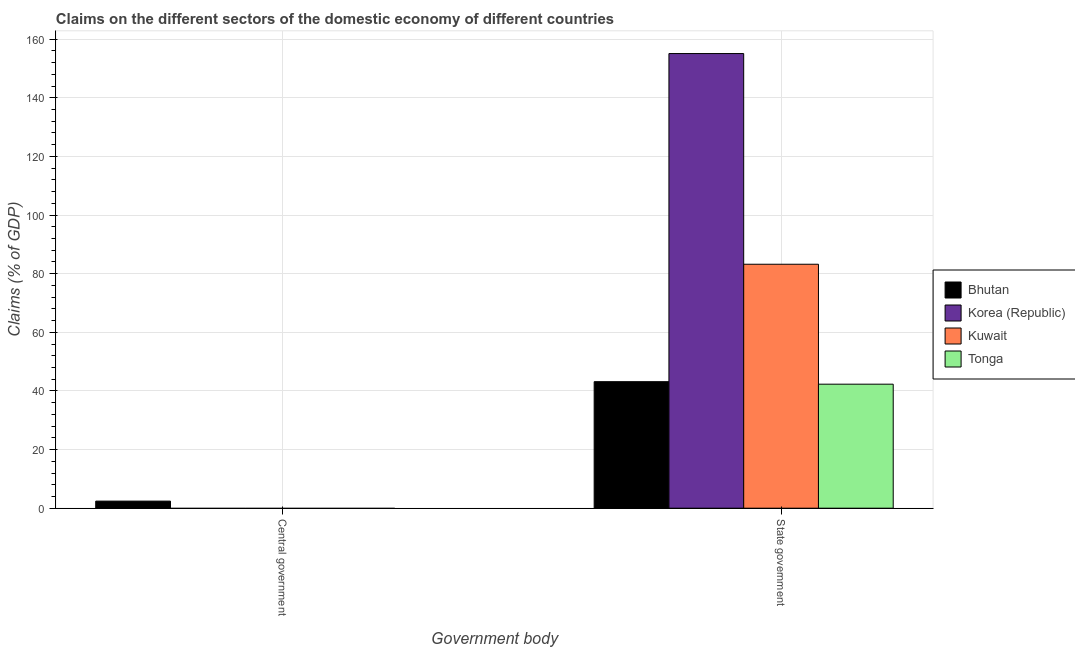How many different coloured bars are there?
Your response must be concise. 4. Are the number of bars per tick equal to the number of legend labels?
Your response must be concise. No. How many bars are there on the 1st tick from the left?
Keep it short and to the point. 1. What is the label of the 2nd group of bars from the left?
Offer a very short reply. State government. Across all countries, what is the maximum claims on central government?
Offer a very short reply. 2.42. Across all countries, what is the minimum claims on state government?
Provide a short and direct response. 42.3. In which country was the claims on state government maximum?
Give a very brief answer. Korea (Republic). What is the total claims on state government in the graph?
Offer a terse response. 323.76. What is the difference between the claims on state government in Tonga and that in Korea (Republic)?
Keep it short and to the point. -112.79. What is the difference between the claims on state government in Korea (Republic) and the claims on central government in Tonga?
Offer a very short reply. 155.09. What is the average claims on state government per country?
Make the answer very short. 80.94. What is the difference between the claims on state government and claims on central government in Bhutan?
Ensure brevity in your answer.  40.74. In how many countries, is the claims on state government greater than 136 %?
Ensure brevity in your answer.  1. What is the ratio of the claims on state government in Tonga to that in Kuwait?
Give a very brief answer. 0.51. Is the claims on state government in Bhutan less than that in Tonga?
Provide a short and direct response. No. In how many countries, is the claims on state government greater than the average claims on state government taken over all countries?
Offer a terse response. 2. How many bars are there?
Provide a succinct answer. 5. How many countries are there in the graph?
Your response must be concise. 4. What is the difference between two consecutive major ticks on the Y-axis?
Offer a very short reply. 20. Are the values on the major ticks of Y-axis written in scientific E-notation?
Provide a short and direct response. No. What is the title of the graph?
Offer a very short reply. Claims on the different sectors of the domestic economy of different countries. What is the label or title of the X-axis?
Your answer should be compact. Government body. What is the label or title of the Y-axis?
Your answer should be very brief. Claims (% of GDP). What is the Claims (% of GDP) of Bhutan in Central government?
Provide a short and direct response. 2.42. What is the Claims (% of GDP) in Korea (Republic) in Central government?
Your answer should be very brief. 0. What is the Claims (% of GDP) in Bhutan in State government?
Offer a very short reply. 43.16. What is the Claims (% of GDP) of Korea (Republic) in State government?
Your answer should be compact. 155.09. What is the Claims (% of GDP) of Kuwait in State government?
Give a very brief answer. 83.22. What is the Claims (% of GDP) in Tonga in State government?
Offer a very short reply. 42.3. Across all Government body, what is the maximum Claims (% of GDP) of Bhutan?
Ensure brevity in your answer.  43.16. Across all Government body, what is the maximum Claims (% of GDP) of Korea (Republic)?
Give a very brief answer. 155.09. Across all Government body, what is the maximum Claims (% of GDP) in Kuwait?
Give a very brief answer. 83.22. Across all Government body, what is the maximum Claims (% of GDP) in Tonga?
Keep it short and to the point. 42.3. Across all Government body, what is the minimum Claims (% of GDP) in Bhutan?
Your answer should be very brief. 2.42. Across all Government body, what is the minimum Claims (% of GDP) of Korea (Republic)?
Make the answer very short. 0. What is the total Claims (% of GDP) of Bhutan in the graph?
Your answer should be compact. 45.57. What is the total Claims (% of GDP) in Korea (Republic) in the graph?
Ensure brevity in your answer.  155.09. What is the total Claims (% of GDP) of Kuwait in the graph?
Give a very brief answer. 83.22. What is the total Claims (% of GDP) of Tonga in the graph?
Ensure brevity in your answer.  42.3. What is the difference between the Claims (% of GDP) in Bhutan in Central government and that in State government?
Provide a succinct answer. -40.74. What is the difference between the Claims (% of GDP) in Bhutan in Central government and the Claims (% of GDP) in Korea (Republic) in State government?
Give a very brief answer. -152.67. What is the difference between the Claims (% of GDP) of Bhutan in Central government and the Claims (% of GDP) of Kuwait in State government?
Offer a very short reply. -80.8. What is the difference between the Claims (% of GDP) of Bhutan in Central government and the Claims (% of GDP) of Tonga in State government?
Your response must be concise. -39.89. What is the average Claims (% of GDP) of Bhutan per Government body?
Give a very brief answer. 22.79. What is the average Claims (% of GDP) of Korea (Republic) per Government body?
Offer a terse response. 77.54. What is the average Claims (% of GDP) in Kuwait per Government body?
Make the answer very short. 41.61. What is the average Claims (% of GDP) of Tonga per Government body?
Your answer should be very brief. 21.15. What is the difference between the Claims (% of GDP) in Bhutan and Claims (% of GDP) in Korea (Republic) in State government?
Offer a terse response. -111.93. What is the difference between the Claims (% of GDP) in Bhutan and Claims (% of GDP) in Kuwait in State government?
Ensure brevity in your answer.  -40.06. What is the difference between the Claims (% of GDP) in Bhutan and Claims (% of GDP) in Tonga in State government?
Keep it short and to the point. 0.85. What is the difference between the Claims (% of GDP) of Korea (Republic) and Claims (% of GDP) of Kuwait in State government?
Give a very brief answer. 71.87. What is the difference between the Claims (% of GDP) in Korea (Republic) and Claims (% of GDP) in Tonga in State government?
Provide a succinct answer. 112.79. What is the difference between the Claims (% of GDP) of Kuwait and Claims (% of GDP) of Tonga in State government?
Your answer should be compact. 40.91. What is the ratio of the Claims (% of GDP) in Bhutan in Central government to that in State government?
Provide a short and direct response. 0.06. What is the difference between the highest and the second highest Claims (% of GDP) in Bhutan?
Provide a succinct answer. 40.74. What is the difference between the highest and the lowest Claims (% of GDP) of Bhutan?
Provide a succinct answer. 40.74. What is the difference between the highest and the lowest Claims (% of GDP) of Korea (Republic)?
Give a very brief answer. 155.09. What is the difference between the highest and the lowest Claims (% of GDP) of Kuwait?
Your answer should be very brief. 83.22. What is the difference between the highest and the lowest Claims (% of GDP) in Tonga?
Make the answer very short. 42.3. 